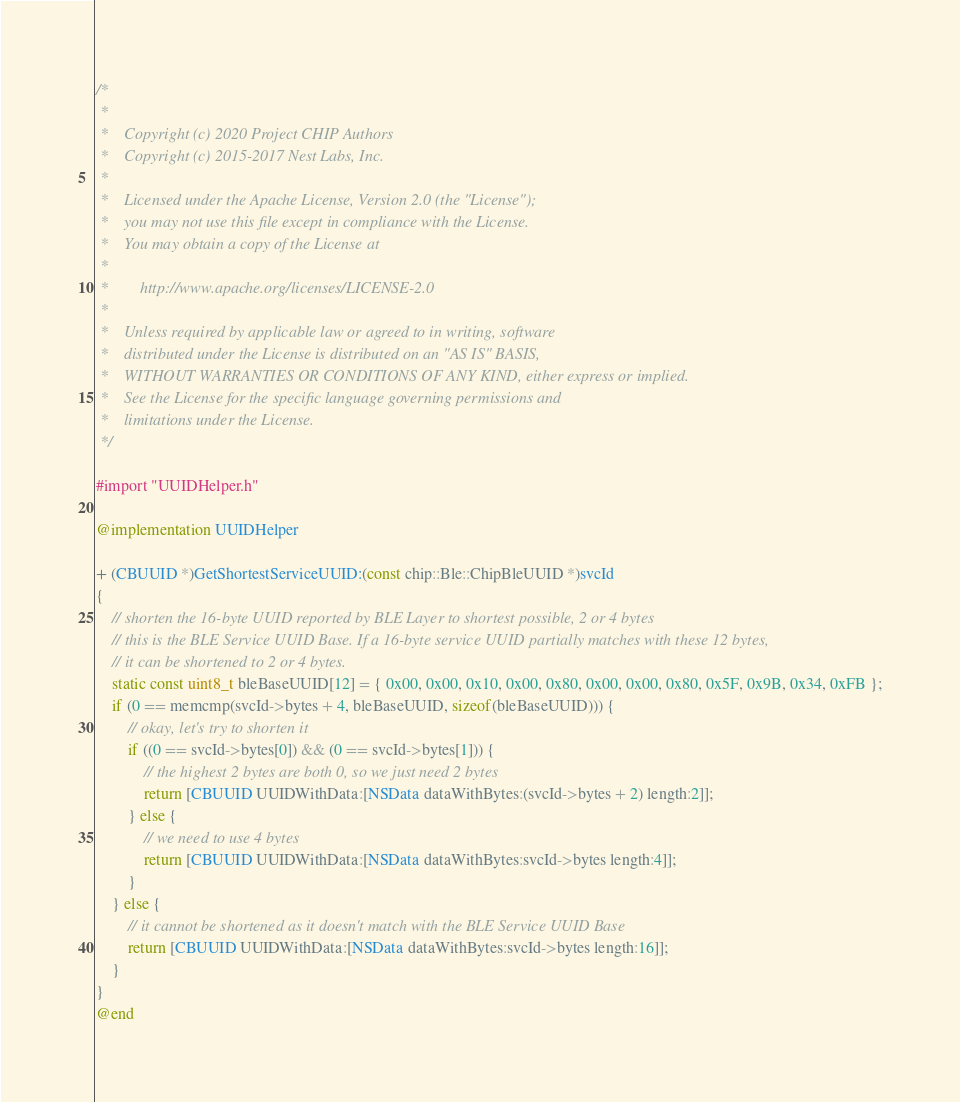<code> <loc_0><loc_0><loc_500><loc_500><_ObjectiveC_>/*
 *
 *    Copyright (c) 2020 Project CHIP Authors
 *    Copyright (c) 2015-2017 Nest Labs, Inc.
 *
 *    Licensed under the Apache License, Version 2.0 (the "License");
 *    you may not use this file except in compliance with the License.
 *    You may obtain a copy of the License at
 *
 *        http://www.apache.org/licenses/LICENSE-2.0
 *
 *    Unless required by applicable law or agreed to in writing, software
 *    distributed under the License is distributed on an "AS IS" BASIS,
 *    WITHOUT WARRANTIES OR CONDITIONS OF ANY KIND, either express or implied.
 *    See the License for the specific language governing permissions and
 *    limitations under the License.
 */

#import "UUIDHelper.h"

@implementation UUIDHelper

+ (CBUUID *)GetShortestServiceUUID:(const chip::Ble::ChipBleUUID *)svcId
{
    // shorten the 16-byte UUID reported by BLE Layer to shortest possible, 2 or 4 bytes
    // this is the BLE Service UUID Base. If a 16-byte service UUID partially matches with these 12 bytes,
    // it can be shortened to 2 or 4 bytes.
    static const uint8_t bleBaseUUID[12] = { 0x00, 0x00, 0x10, 0x00, 0x80, 0x00, 0x00, 0x80, 0x5F, 0x9B, 0x34, 0xFB };
    if (0 == memcmp(svcId->bytes + 4, bleBaseUUID, sizeof(bleBaseUUID))) {
        // okay, let's try to shorten it
        if ((0 == svcId->bytes[0]) && (0 == svcId->bytes[1])) {
            // the highest 2 bytes are both 0, so we just need 2 bytes
            return [CBUUID UUIDWithData:[NSData dataWithBytes:(svcId->bytes + 2) length:2]];
        } else {
            // we need to use 4 bytes
            return [CBUUID UUIDWithData:[NSData dataWithBytes:svcId->bytes length:4]];
        }
    } else {
        // it cannot be shortened as it doesn't match with the BLE Service UUID Base
        return [CBUUID UUIDWithData:[NSData dataWithBytes:svcId->bytes length:16]];
    }
}
@end
</code> 